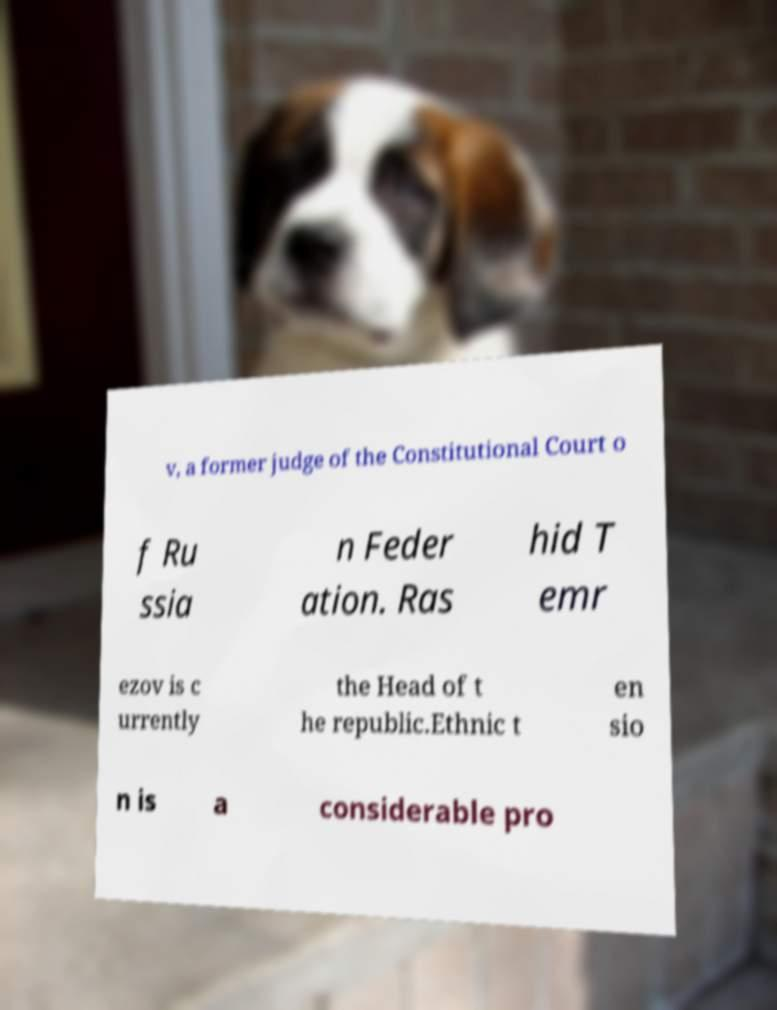Can you read and provide the text displayed in the image?This photo seems to have some interesting text. Can you extract and type it out for me? v, a former judge of the Constitutional Court o f Ru ssia n Feder ation. Ras hid T emr ezov is c urrently the Head of t he republic.Ethnic t en sio n is a considerable pro 